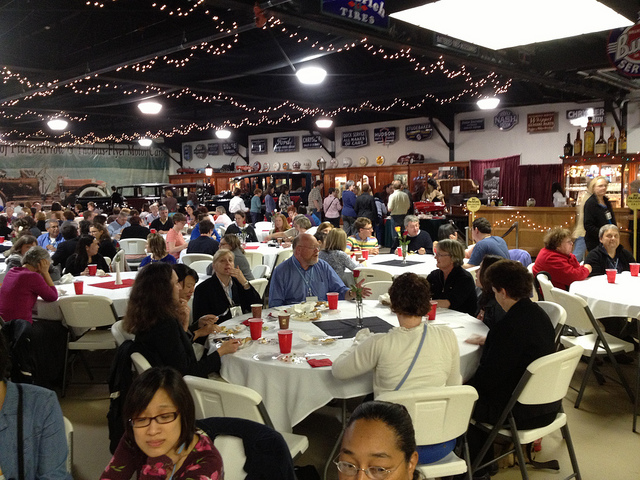Please identify all text content in this image. SER 